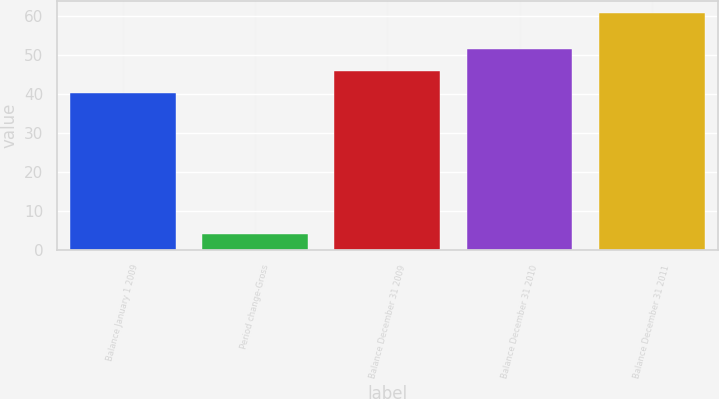<chart> <loc_0><loc_0><loc_500><loc_500><bar_chart><fcel>Balance January 1 2009<fcel>Period change-Gross<fcel>Balance December 31 2009<fcel>Balance December 31 2010<fcel>Balance December 31 2011<nl><fcel>40.3<fcel>4.1<fcel>45.98<fcel>51.66<fcel>60.9<nl></chart> 